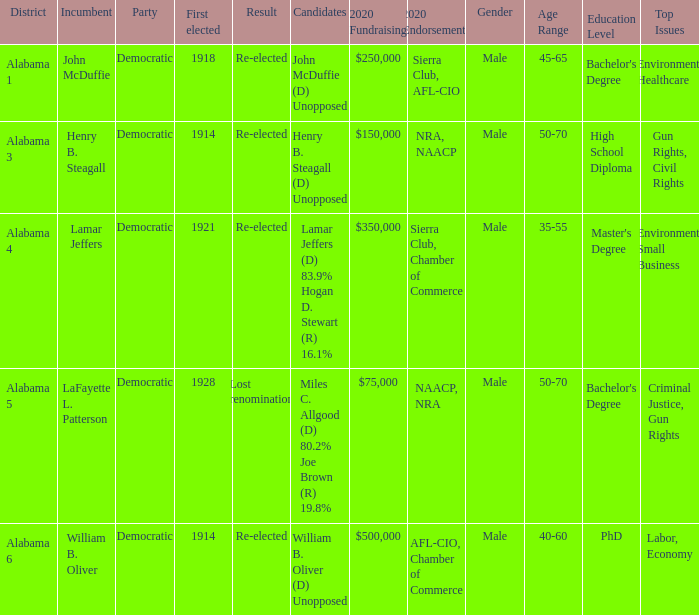How many in lost renomination results were elected first? 1928.0. 